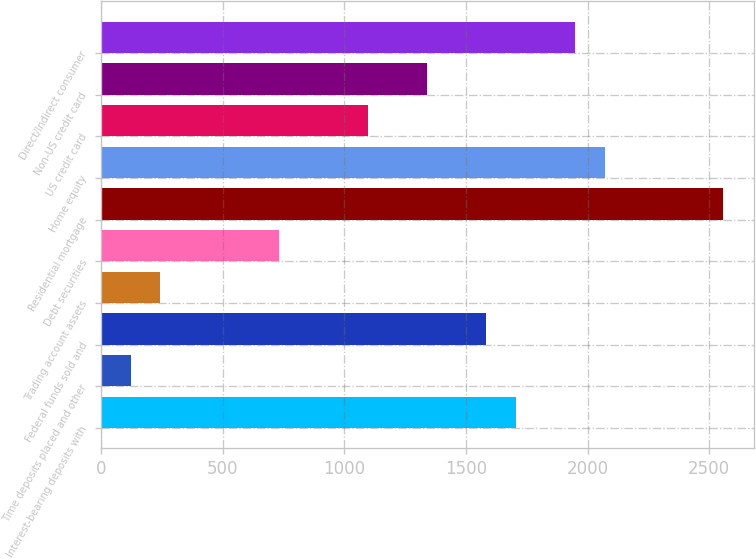Convert chart. <chart><loc_0><loc_0><loc_500><loc_500><bar_chart><fcel>Interest-bearing deposits with<fcel>Time deposits placed and other<fcel>Federal funds sold and<fcel>Trading account assets<fcel>Debt securities<fcel>Residential mortgage<fcel>Home equity<fcel>US credit card<fcel>Non-US credit card<fcel>Direct/Indirect consumer<nl><fcel>1704.8<fcel>122.7<fcel>1583.1<fcel>244.4<fcel>731.2<fcel>2556.7<fcel>2069.9<fcel>1096.3<fcel>1339.7<fcel>1948.2<nl></chart> 